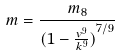Convert formula to latex. <formula><loc_0><loc_0><loc_500><loc_500>m = \frac { m _ { 8 } } { ( { 1 - \frac { v ^ { 9 } } { k ^ { 9 } } ) } ^ { 7 / 9 } }</formula> 